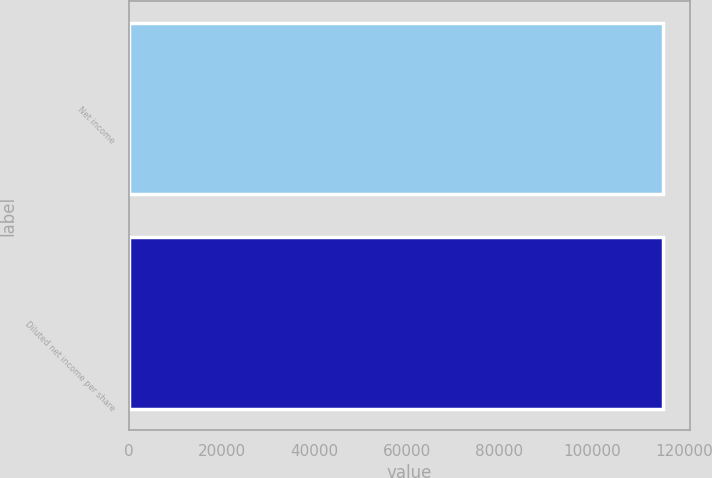Convert chart to OTSL. <chart><loc_0><loc_0><loc_500><loc_500><bar_chart><fcel>Net income<fcel>Diluted net income per share<nl><fcel>115466<fcel>115466<nl></chart> 